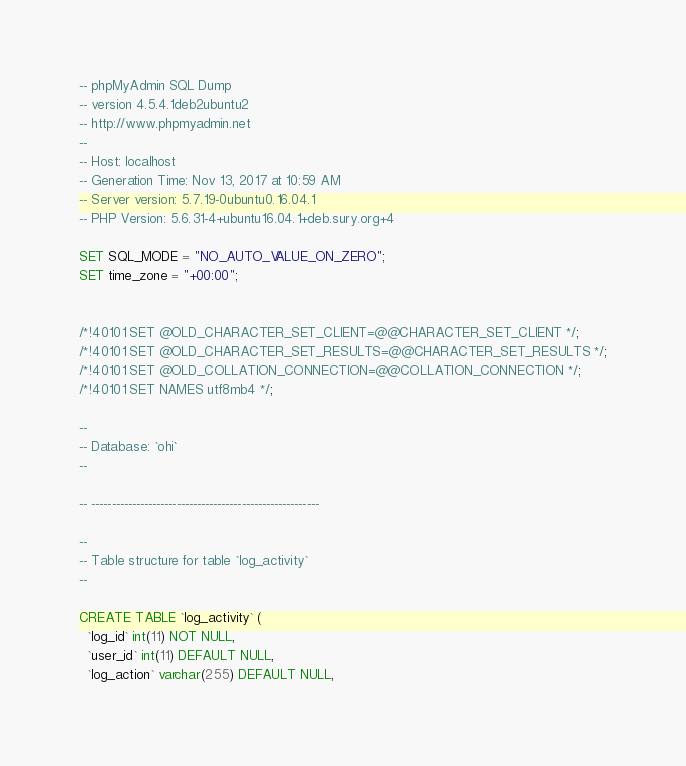<code> <loc_0><loc_0><loc_500><loc_500><_SQL_>-- phpMyAdmin SQL Dump
-- version 4.5.4.1deb2ubuntu2
-- http://www.phpmyadmin.net
--
-- Host: localhost
-- Generation Time: Nov 13, 2017 at 10:59 AM
-- Server version: 5.7.19-0ubuntu0.16.04.1
-- PHP Version: 5.6.31-4+ubuntu16.04.1+deb.sury.org+4

SET SQL_MODE = "NO_AUTO_VALUE_ON_ZERO";
SET time_zone = "+00:00";


/*!40101 SET @OLD_CHARACTER_SET_CLIENT=@@CHARACTER_SET_CLIENT */;
/*!40101 SET @OLD_CHARACTER_SET_RESULTS=@@CHARACTER_SET_RESULTS */;
/*!40101 SET @OLD_COLLATION_CONNECTION=@@COLLATION_CONNECTION */;
/*!40101 SET NAMES utf8mb4 */;

--
-- Database: `ohi`
--

-- --------------------------------------------------------

--
-- Table structure for table `log_activity`
--

CREATE TABLE `log_activity` (
  `log_id` int(11) NOT NULL,
  `user_id` int(11) DEFAULT NULL,
  `log_action` varchar(255) DEFAULT NULL,</code> 